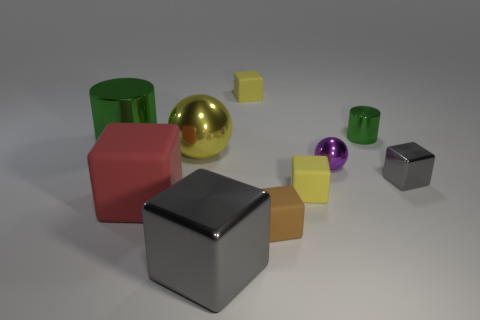How many yellow things are both in front of the tiny green cylinder and to the right of the big yellow object?
Your response must be concise. 1. How many tiny gray blocks are the same material as the big green cylinder?
Keep it short and to the point. 1. The large cube that is the same material as the tiny brown block is what color?
Ensure brevity in your answer.  Red. Is the number of large metal balls less than the number of cyan metal balls?
Ensure brevity in your answer.  No. There is a tiny yellow thing in front of the cylinder to the left of the small yellow thing on the right side of the brown matte cube; what is its material?
Provide a short and direct response. Rubber. What is the yellow sphere made of?
Ensure brevity in your answer.  Metal. Do the small matte thing that is behind the yellow metallic sphere and the metallic ball that is on the left side of the big gray object have the same color?
Make the answer very short. Yes. Is the number of small green shiny objects greater than the number of large green rubber things?
Provide a short and direct response. Yes. What number of big matte things have the same color as the big ball?
Provide a short and direct response. 0. There is a small metal object that is the same shape as the large red object; what is its color?
Ensure brevity in your answer.  Gray. 